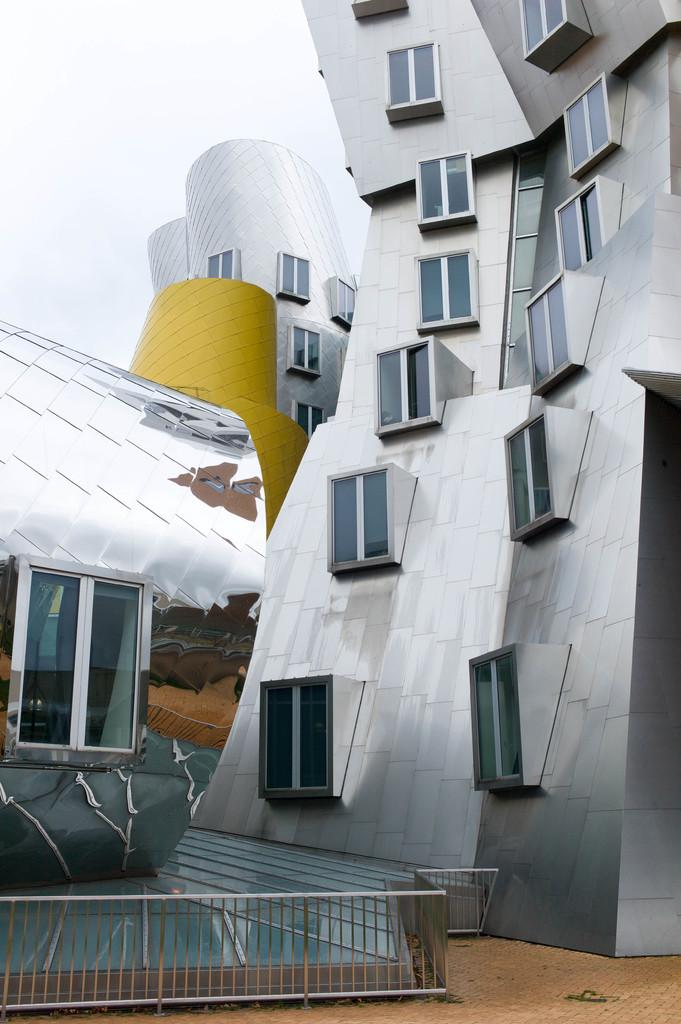What structures are visible in the image? There are buildings in the image. What is the condition of the sky in the image? The sky is cloudy in the image. Is there any quicksand visible in the image? No, there is no quicksand present in the image. What type of thing is depicted interacting with the buildings in the image? There is no specific thing depicted interacting with the buildings in the image; only the buildings and the cloudy sky are present. 